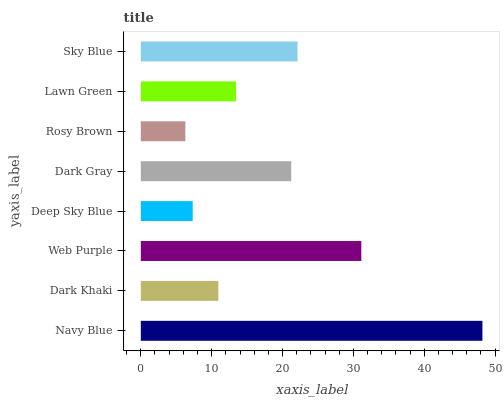Is Rosy Brown the minimum?
Answer yes or no. Yes. Is Navy Blue the maximum?
Answer yes or no. Yes. Is Dark Khaki the minimum?
Answer yes or no. No. Is Dark Khaki the maximum?
Answer yes or no. No. Is Navy Blue greater than Dark Khaki?
Answer yes or no. Yes. Is Dark Khaki less than Navy Blue?
Answer yes or no. Yes. Is Dark Khaki greater than Navy Blue?
Answer yes or no. No. Is Navy Blue less than Dark Khaki?
Answer yes or no. No. Is Dark Gray the high median?
Answer yes or no. Yes. Is Lawn Green the low median?
Answer yes or no. Yes. Is Sky Blue the high median?
Answer yes or no. No. Is Navy Blue the low median?
Answer yes or no. No. 